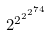Convert formula to latex. <formula><loc_0><loc_0><loc_500><loc_500>2 ^ { 2 ^ { 2 ^ { 2 ^ { 7 4 } } } }</formula> 